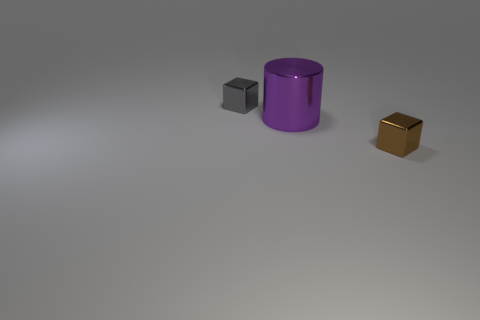Is there anything else that has the same size as the purple cylinder?
Ensure brevity in your answer.  No. How many things are blocks to the left of the small brown metal object or rubber cylinders?
Give a very brief answer. 1. There is a tiny metallic object that is behind the tiny thing that is in front of the gray cube to the left of the purple metal object; what shape is it?
Make the answer very short. Cube. What number of other tiny shiny objects have the same shape as the tiny gray shiny thing?
Keep it short and to the point. 1. Are the tiny brown thing and the tiny gray thing made of the same material?
Provide a succinct answer. Yes. What number of shiny things are left of the small metal block in front of the metal object that is to the left of the big purple cylinder?
Ensure brevity in your answer.  2. Are there any brown things made of the same material as the gray thing?
Your answer should be very brief. Yes. Are there fewer metallic cubes than objects?
Provide a short and direct response. Yes. There is a small metallic thing that is behind the large cylinder; is its color the same as the big cylinder?
Offer a terse response. No. Is the number of gray objects behind the gray metal thing less than the number of yellow metal cubes?
Ensure brevity in your answer.  No. 